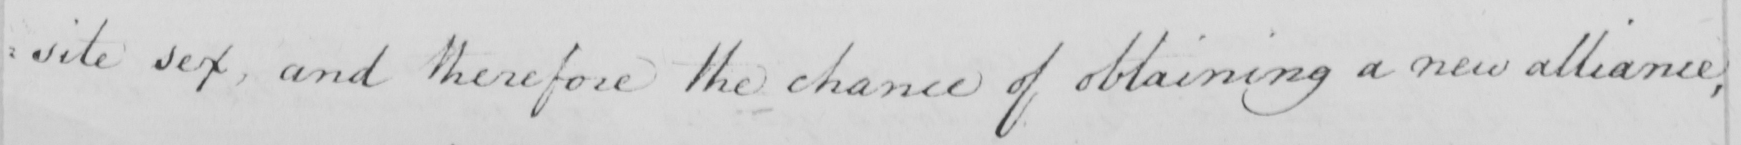Transcribe the text shown in this historical manuscript line. : site sex and therefore the chance of obtaining a new alliance , 